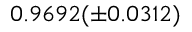Convert formula to latex. <formula><loc_0><loc_0><loc_500><loc_500>0 . 9 6 9 2 ( \pm 0 . 0 3 1 2 )</formula> 